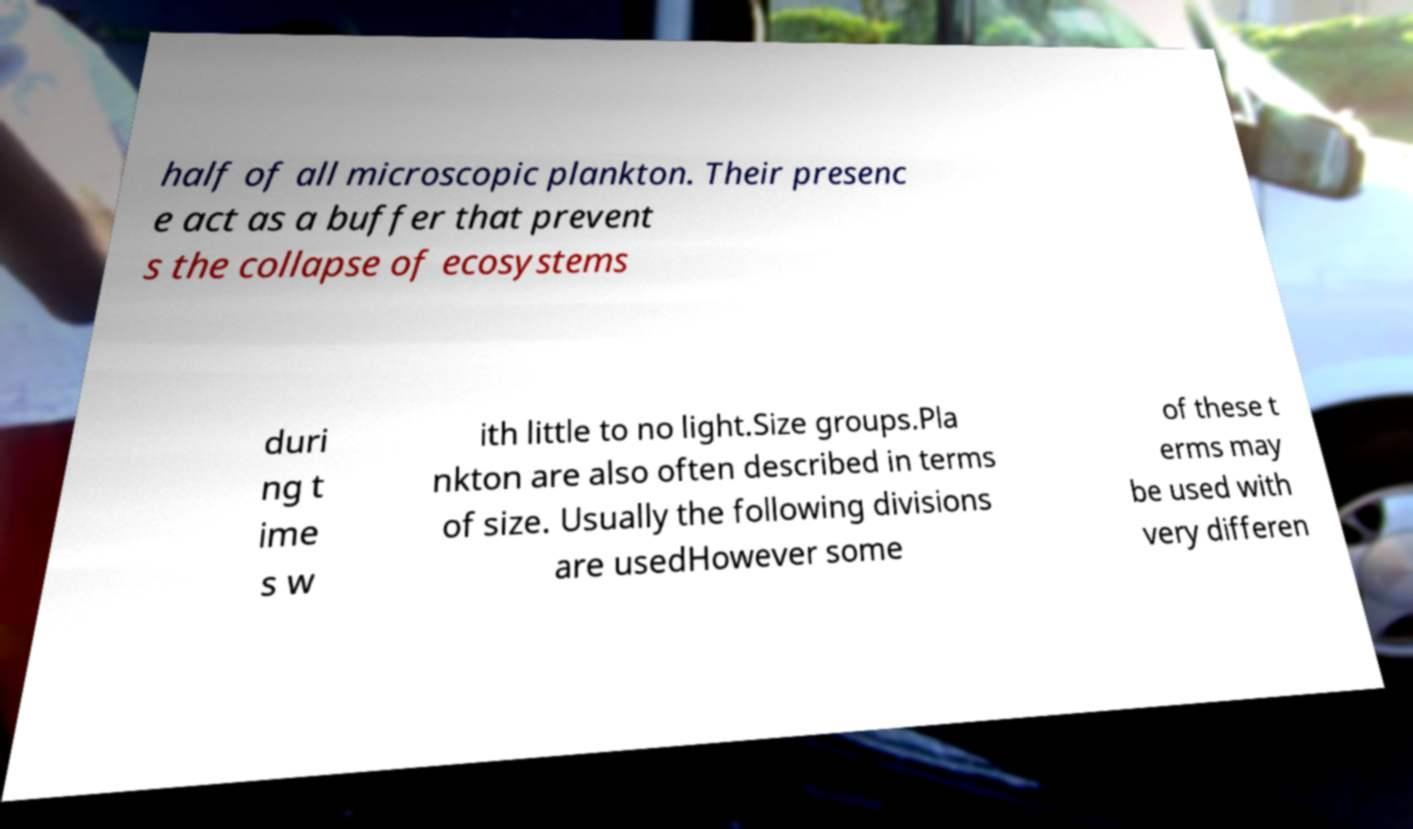Could you assist in decoding the text presented in this image and type it out clearly? half of all microscopic plankton. Their presenc e act as a buffer that prevent s the collapse of ecosystems duri ng t ime s w ith little to no light.Size groups.Pla nkton are also often described in terms of size. Usually the following divisions are usedHowever some of these t erms may be used with very differen 